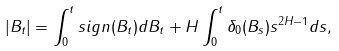Convert formula to latex. <formula><loc_0><loc_0><loc_500><loc_500>| B _ { t } | = \int _ { 0 } ^ { t } s i g n ( B _ { t } ) d B _ { t } + H \int _ { 0 } ^ { t } \delta _ { 0 } ( B _ { s } ) s ^ { 2 H - 1 } d s ,</formula> 